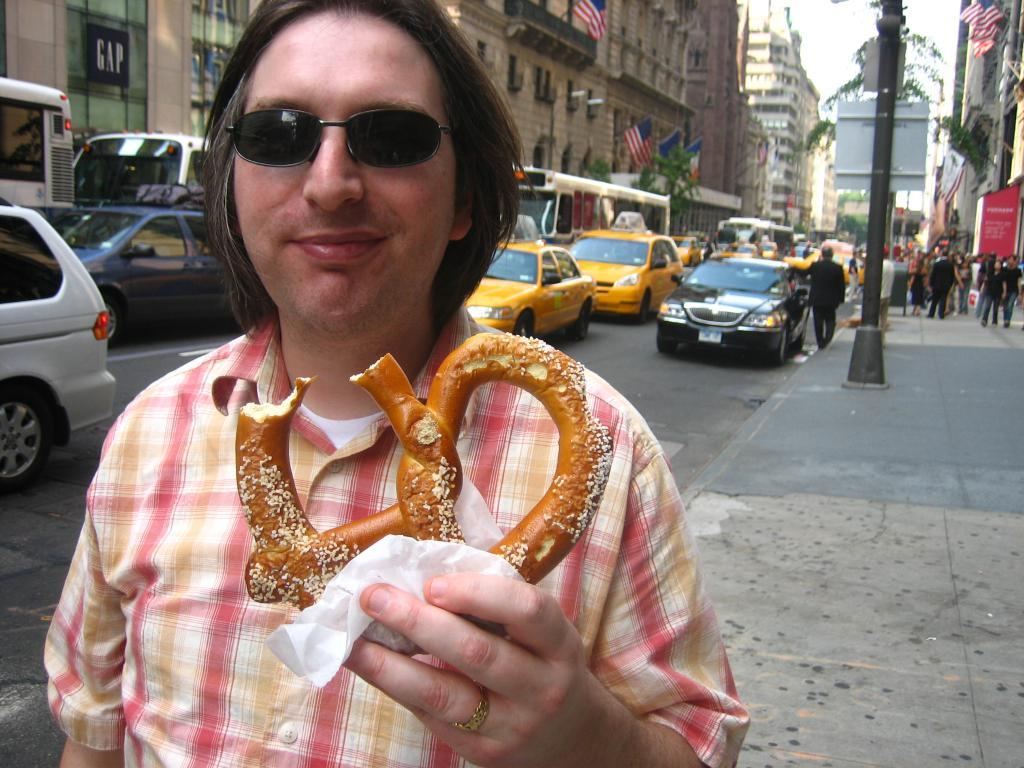What is the person in the image holding? The person is holding bread. What can be seen in the background of the image? There is a building, flags, a tree, vehicles, a sign board, and a group of persons standing in the background of the image. Is there quicksand in the image? There is no quicksand present in the image. 